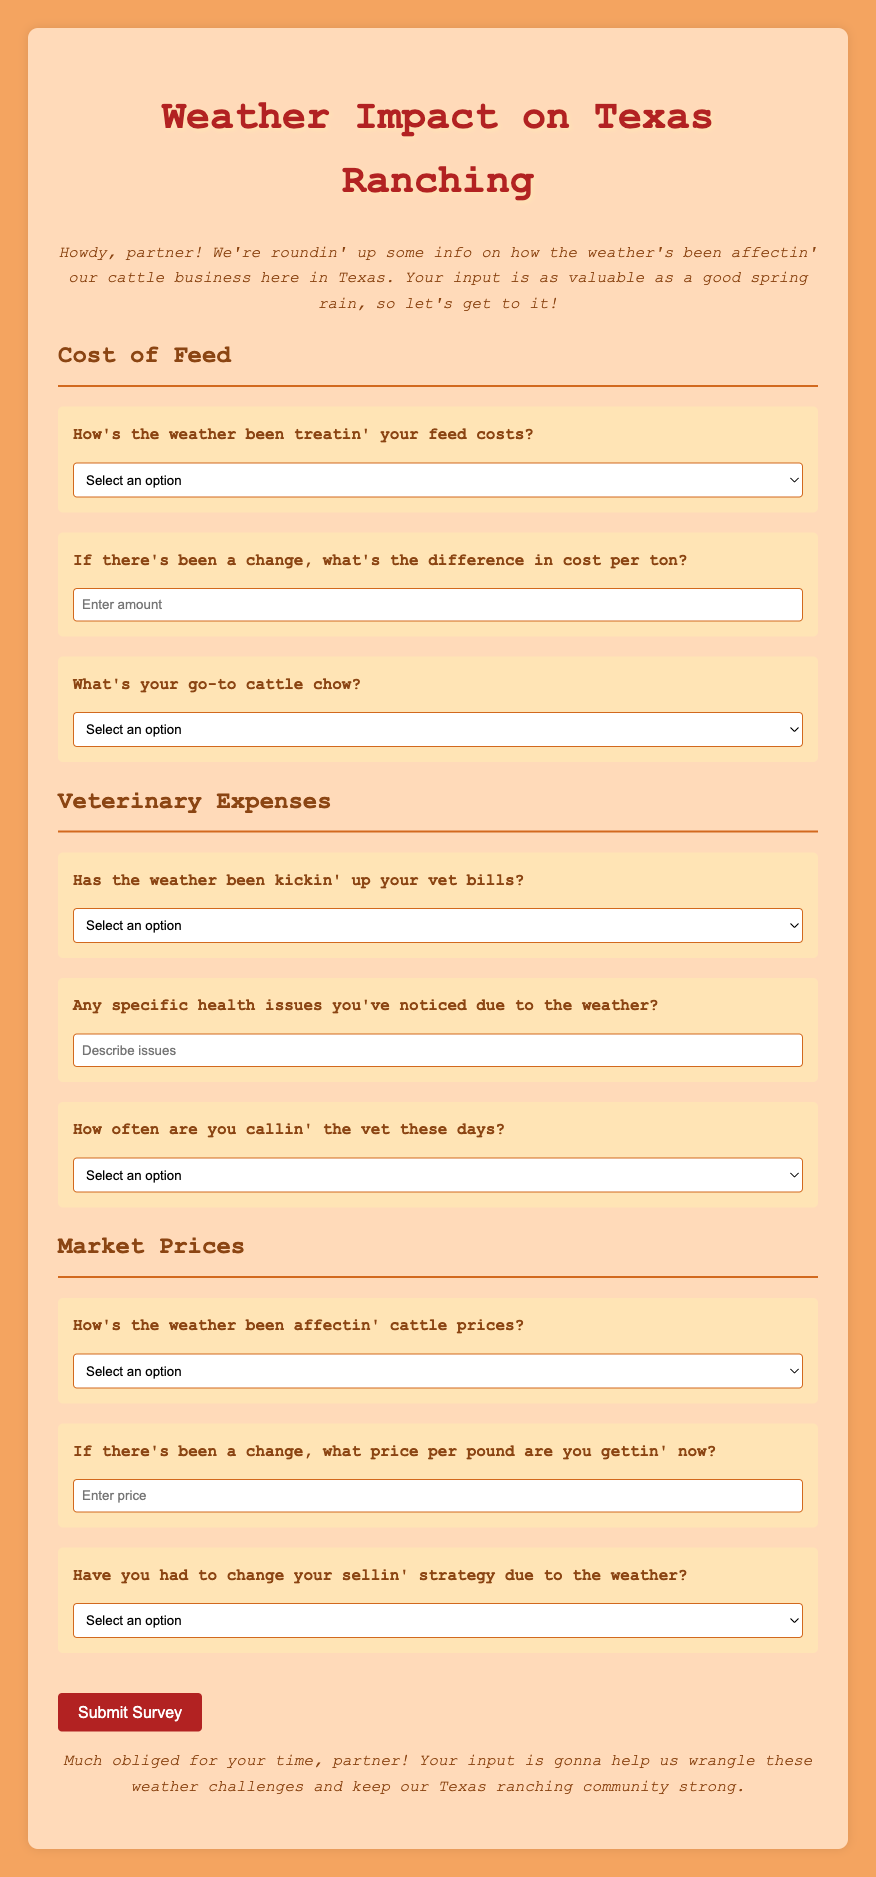What is the title of the survey? The title of the survey is prominently displayed at the top of the document.
Answer: Weather Impact on Texas Ranching What is the background color of the survey form? The background color of the survey form is specified in the style section of the document.
Answer: #FFDAB9 How many options are provided for the "Cost of Feed" question? The question regarding "Cost of Feed" has multiple-choices, which can be counted directly from the document.
Answer: Four options What does the introduction say about the information being gathered? The introduction gives a welcoming tone and states the purpose of gathering information related to the weather's impact on cattle.
Answer: It's valuable for weather impact What is one type of cattle feed mentioned in the survey? The survey lists choices for cattle feed, which can be directly referenced.
Answer: Hay What is the color of the button in the survey? The button's background color and style details are included within the styling code.
Answer: #B22222 What are ranchers asked about regarding veterinary expenses? The survey inquires about the impact of weather on veterinary expenses through a specific question.
Answer: Vet bills How does the survey ask about changes in cattle prices? The survey uses a select dropdown to inquire about the impact of weather on market prices specifically for cattle.
Answer: How's the weather been affectin' cattle prices? What type of issues does the survey ask about related to veterinary concerns? The document contains a question specifically aimed at understanding health issues influenced by the weather.
Answer: Specific health issues Have ranchers been asked if they've had to change their selling strategy? This question is included in the market prices section, asking about potential changes due to weather.
Answer: Yes 